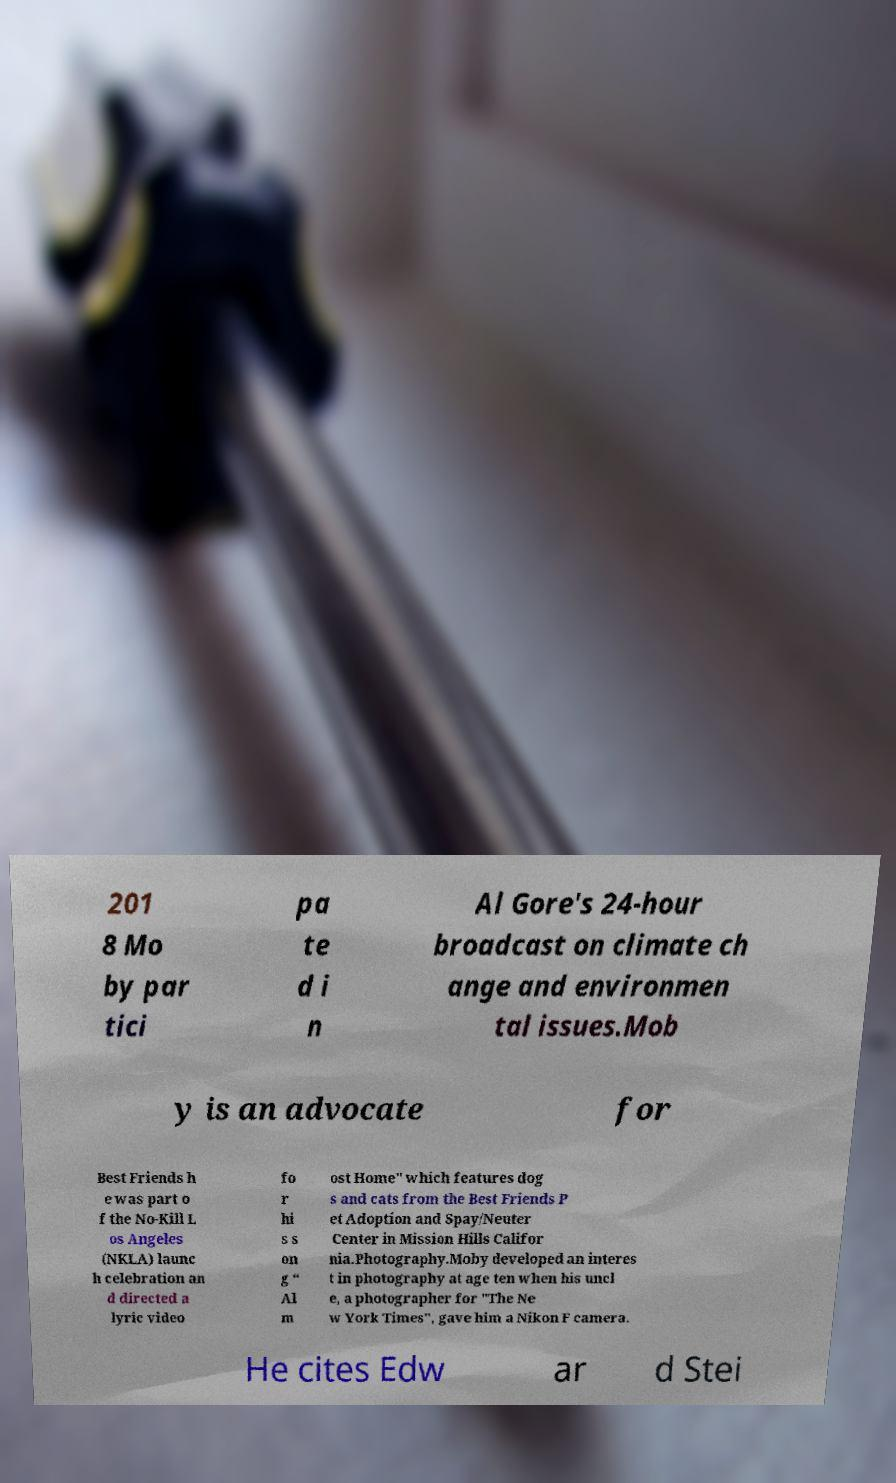Can you accurately transcribe the text from the provided image for me? 201 8 Mo by par tici pa te d i n Al Gore's 24-hour broadcast on climate ch ange and environmen tal issues.Mob y is an advocate for Best Friends h e was part o f the No-Kill L os Angeles (NKLA) launc h celebration an d directed a lyric video fo r hi s s on g “ Al m ost Home" which features dog s and cats from the Best Friends P et Adoption and Spay/Neuter Center in Mission Hills Califor nia.Photography.Moby developed an interes t in photography at age ten when his uncl e, a photographer for "The Ne w York Times", gave him a Nikon F camera. He cites Edw ar d Stei 